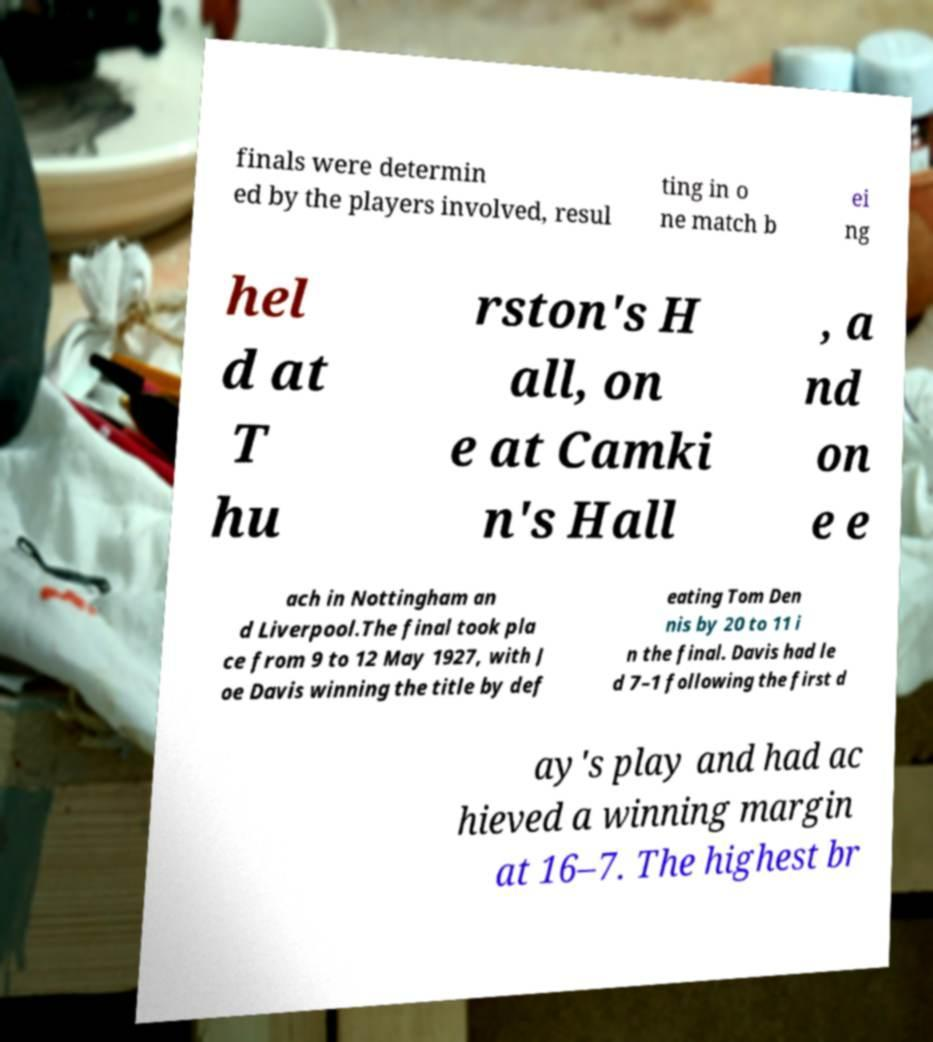There's text embedded in this image that I need extracted. Can you transcribe it verbatim? finals were determin ed by the players involved, resul ting in o ne match b ei ng hel d at T hu rston's H all, on e at Camki n's Hall , a nd on e e ach in Nottingham an d Liverpool.The final took pla ce from 9 to 12 May 1927, with J oe Davis winning the title by def eating Tom Den nis by 20 to 11 i n the final. Davis had le d 7–1 following the first d ay's play and had ac hieved a winning margin at 16–7. The highest br 